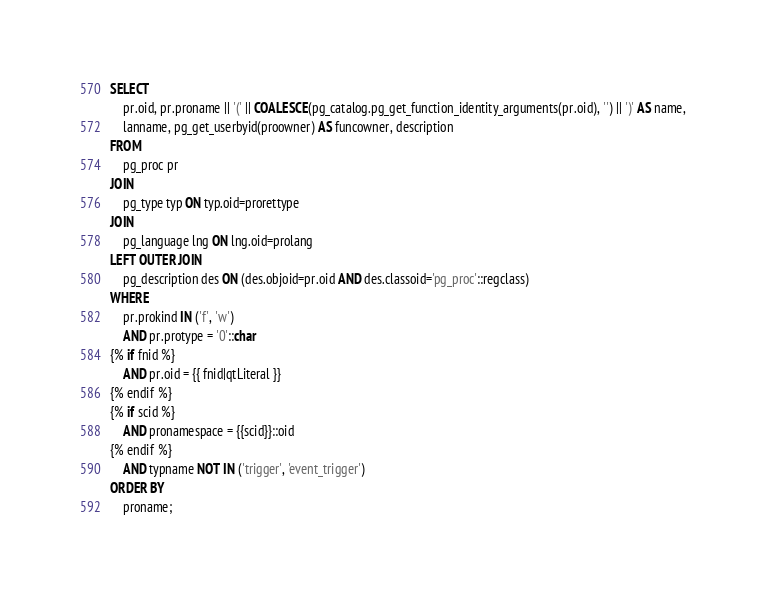Convert code to text. <code><loc_0><loc_0><loc_500><loc_500><_SQL_>SELECT
    pr.oid, pr.proname || '(' || COALESCE(pg_catalog.pg_get_function_identity_arguments(pr.oid), '') || ')' AS name,
    lanname, pg_get_userbyid(proowner) AS funcowner, description
FROM
    pg_proc pr
JOIN
    pg_type typ ON typ.oid=prorettype
JOIN
    pg_language lng ON lng.oid=prolang
LEFT OUTER JOIN
    pg_description des ON (des.objoid=pr.oid AND des.classoid='pg_proc'::regclass)
WHERE
    pr.prokind IN ('f', 'w')
    AND pr.protype = '0'::char
{% if fnid %}
    AND pr.oid = {{ fnid|qtLiteral }}
{% endif %}
{% if scid %}
    AND pronamespace = {{scid}}::oid
{% endif %}
    AND typname NOT IN ('trigger', 'event_trigger')
ORDER BY
    proname;
</code> 